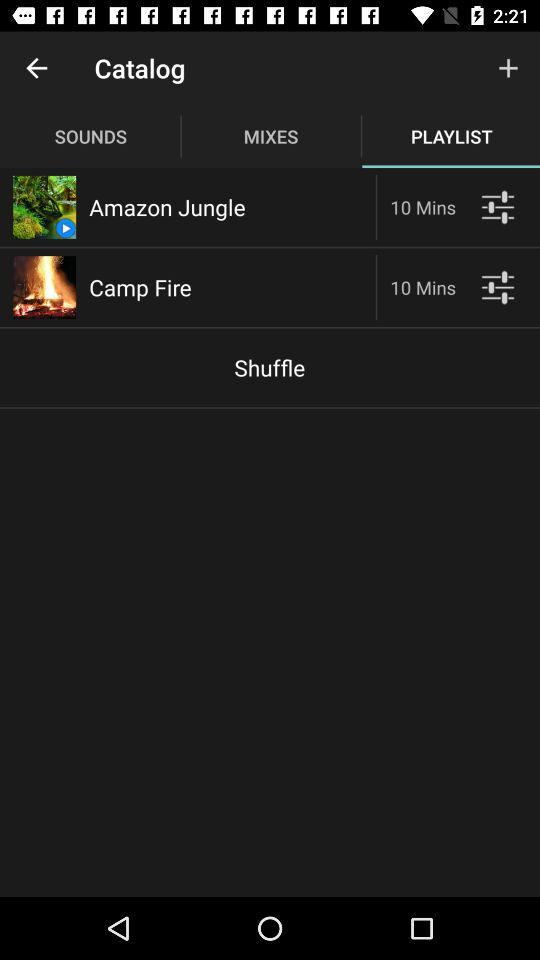What is the duration of the "Amazon Jungle"? The duration is 10 minutes. 